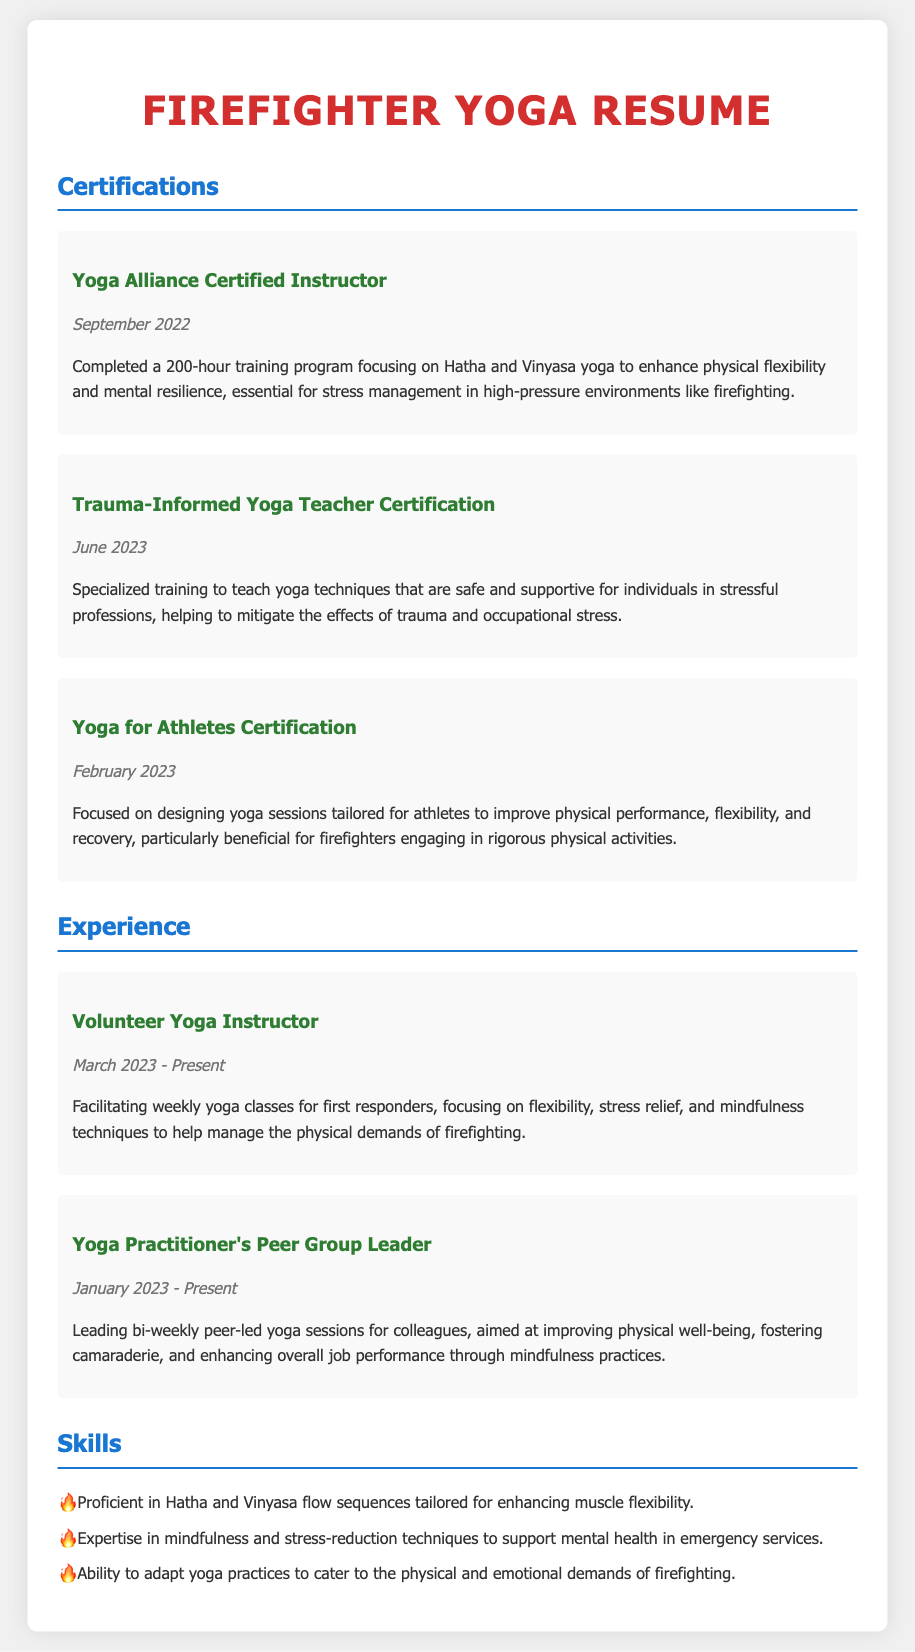what is the title of the resume? The title is prominently displayed at the top of the document, indicating the personal focus and relevance of the certification and experience detailed within.
Answer: Firefighter Yoga Resume when did the individual receive their Yoga Alliance Certification? The specific date of certification is listed clearly in the document under the relevant section.
Answer: September 2022 how many certifications are listed in the resume? The total number of certifications includes those that focus on various aspects of yoga training relevant to firefighting.
Answer: Three what is the focus of the Trauma-Informed Yoga Teacher Certification? This certification is specifically mentioned to address the needs of professionals exposed to stress, which is aligned with the challenges faced by firefighters.
Answer: Safe and supportive techniques for stressful professions who is the targeted audience for the volunteer yoga classes mentioned? The document explicitly states the group in focus for the volunteering duties detailed therein, related to the individual's professional field.
Answer: First responders what are the goals of the bi-weekly peer-led yoga sessions? The document outlines the intended outcomes of the yoga sessions, emphasizing personal and professional growth among participants.
Answer: Improving physical well-being, fostering camaraderie, and enhancing overall job performance which yoga styles are the individual proficient in? The resume highlights specific styles that are tailored for enhancing further well-being and flexibility in the demanding job of firefighting.
Answer: Hatha and Vinyasa what is one skill related to mindfulness mentioned in the document? The skills section indicates a particular focus on a practice aimed at supporting mental health, relevant to high-stress professions like firefighting.
Answer: Stress-reduction techniques 